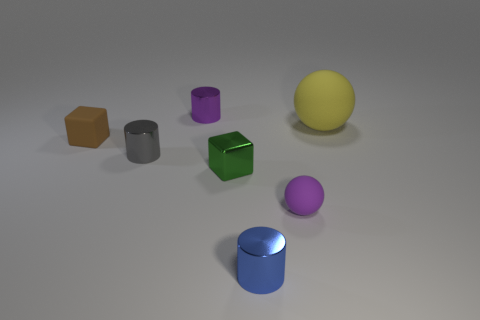How is the lighting affecting the appearance of the objects in the image? The lighting in the image appears to be coming from above, creating soft shadows beneath each object. The smooth, shiny surfaces of the objects reflect the light, highlighting their colors and contributing to a sense of depth and dimensionality in the space. 